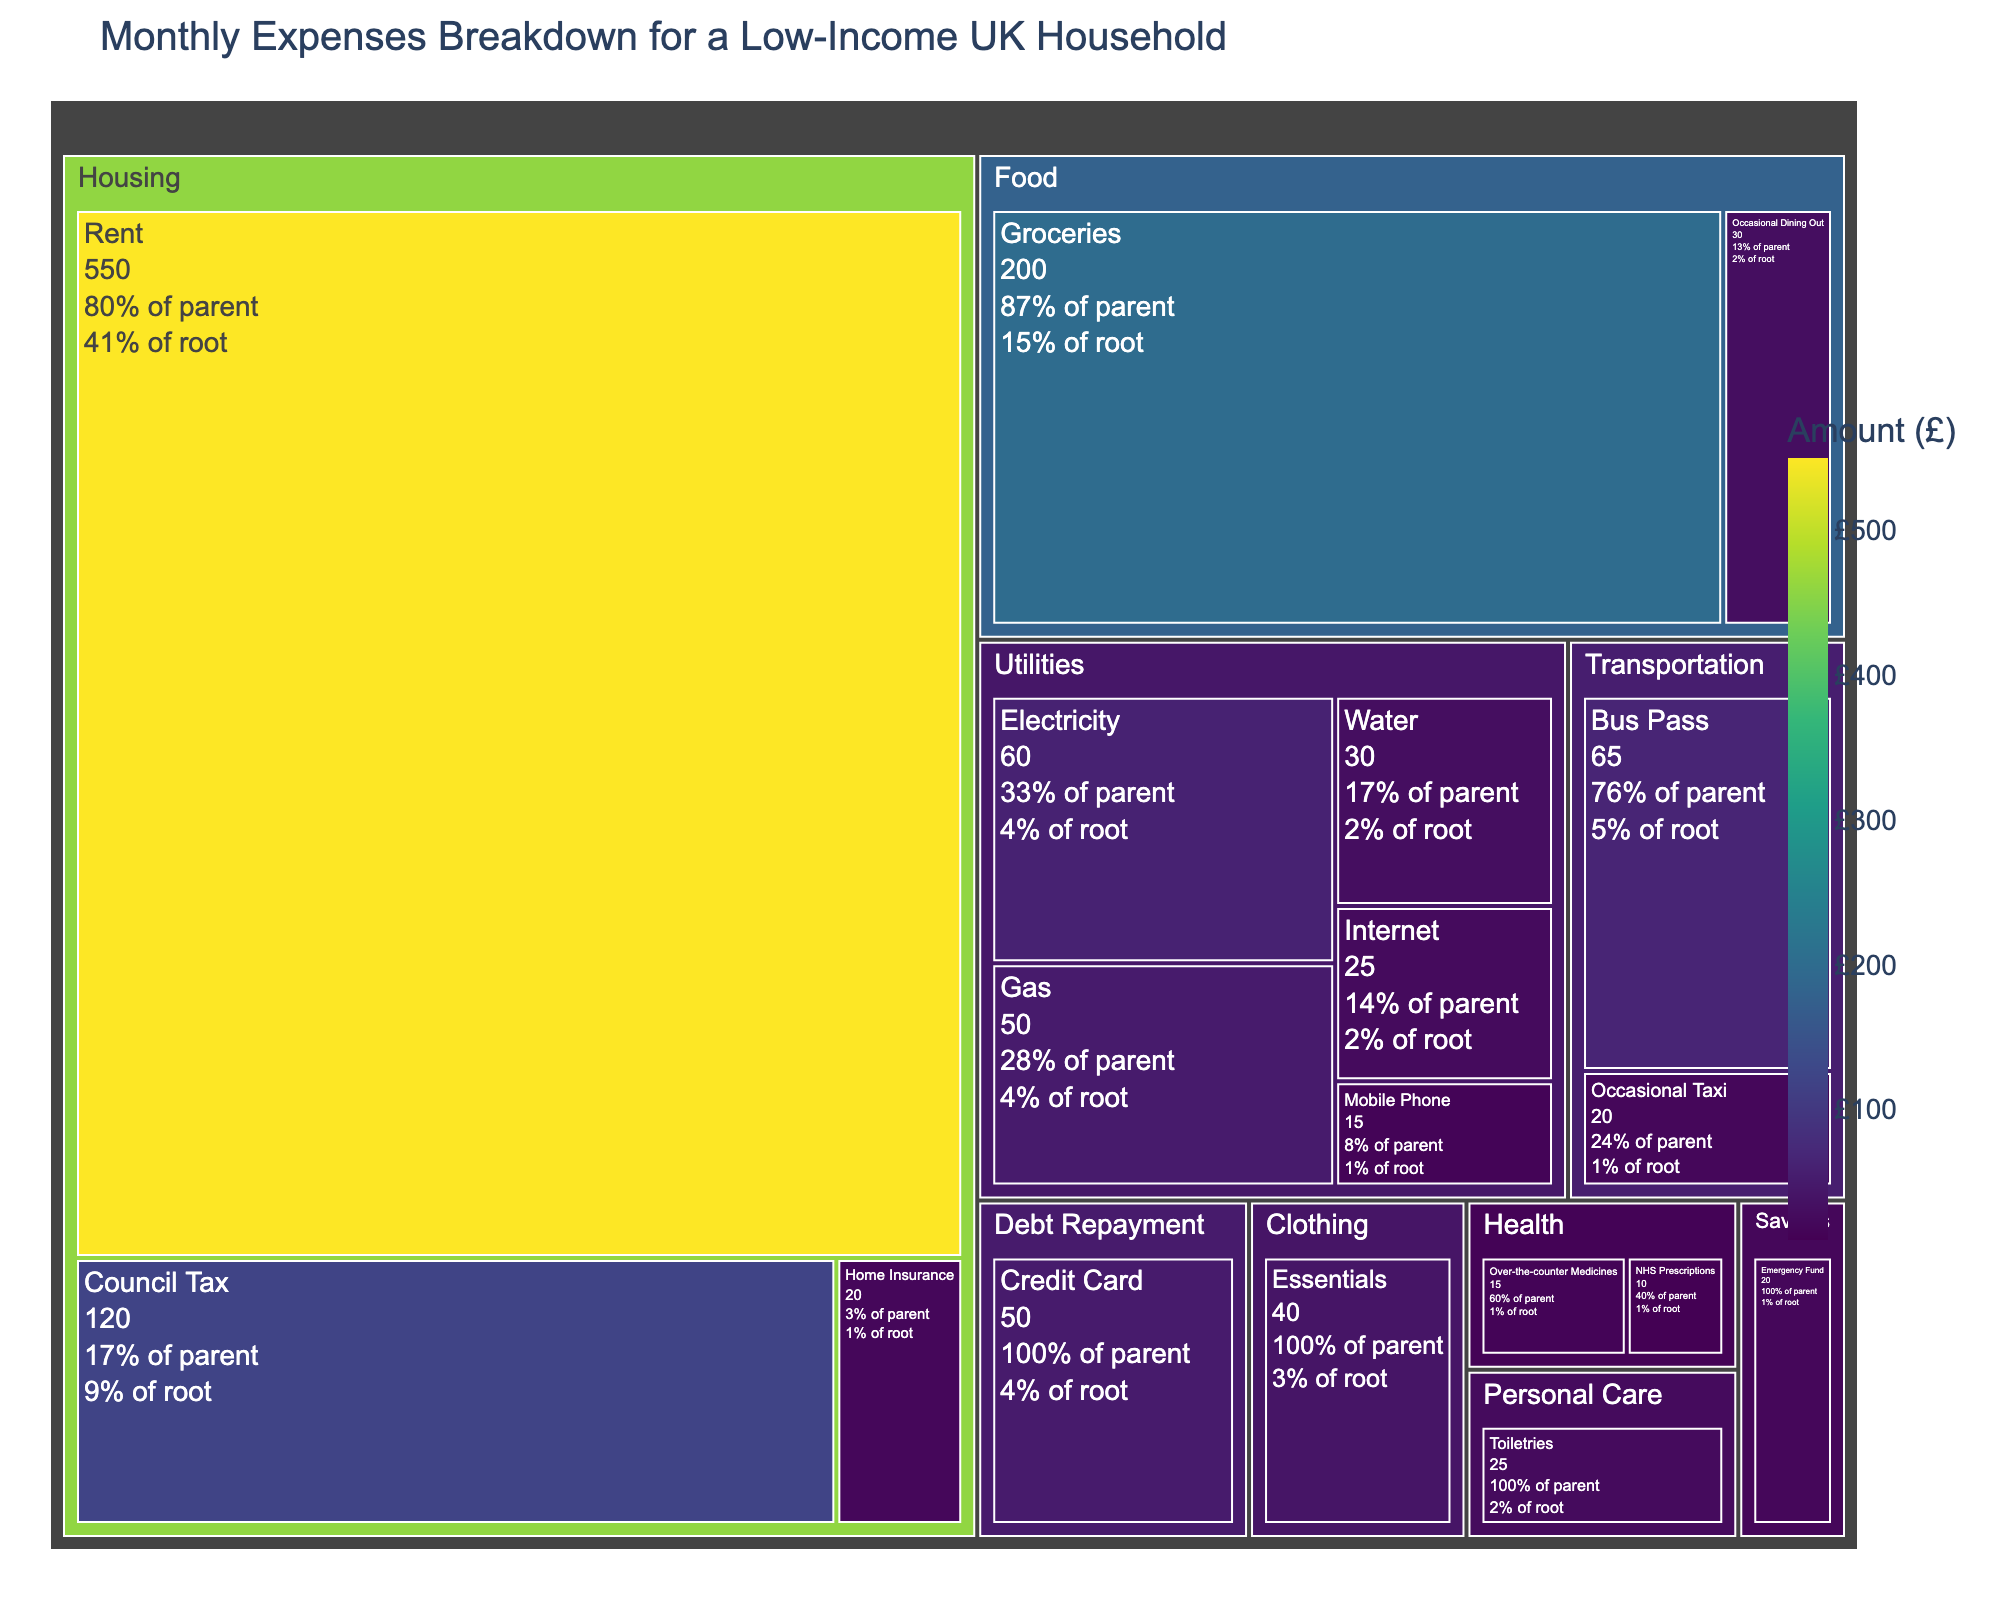What's the title of the treemap? The title of a chart is often placed at the top, providing a summary of what the chart represents. In the treemap, the title "Monthly Expenses Breakdown for a Low-Income UK Household" is visible at the top of the chart.
Answer: Monthly Expenses Breakdown for a Low-Income UK Household Which category has the highest expense? To find the category with the highest expense, look for the largest and darkest block in the treemap. The category "Housing" occupies the most space and is the darkest, indicating the highest expenses.
Answer: Housing What's the total amount spent on utilities? Add up the expenses in all subcategories under Utilities: Electricity (£60), Gas (£50), Water (£30), Internet (£25), and Mobile Phone (£15). The total is 60 + 50 + 30 + 25 + 15 = £180.
Answer: £180 Which category has the smallest expense and what is it? Identify the smallest and lightest colored block in the treemap. The smallest expense is in the "Health" category under the "NHS Prescriptions" subcategory.
Answer: NHS Prescriptions, £10 How much more is spent on Groceries compared to Bus Pass? Locate the amounts for Groceries (£200) and Bus Pass (£65) in the treemap. Calculate the difference: 200 - 65 = £135.
Answer: £135 What percentage of the total expenses does rent account for? Find the amount for Rent (£550) and sum all expenses to get the total. The total expenses are £1300. Calculate the percentage: (550 / 1300) * 100 ≈ 42.31%.
Answer: 42.31% Which subcategory in Housing has the least expense? Look within the Housing category for the smallest subcategory. "Home Insurance" has the least expense at £20.
Answer: Home Insurance What is the combined amount spent on Transportation, Health, and Personal Care? Add the expenses in Transportation (£65 + £20), Health (£10 + £15), and Personal Care (£25): (65 + 20) + (10 + 15) + 25 = 135.
Answer: £135 Is more money spent on Utilities than on Food? Compare the total expenses of Utilities (£180) with Food (£230). Since 230 is greater than 180, more money is spent on Food.
Answer: No What fraction of the total expenses does debt repayment form? Locate the amount for Debt Repayment (£50) and divide by the total expenses (£1300): 50 / 1300 = 1/26 ≈ 0.0385 (fractional form).
Answer: 1/26 